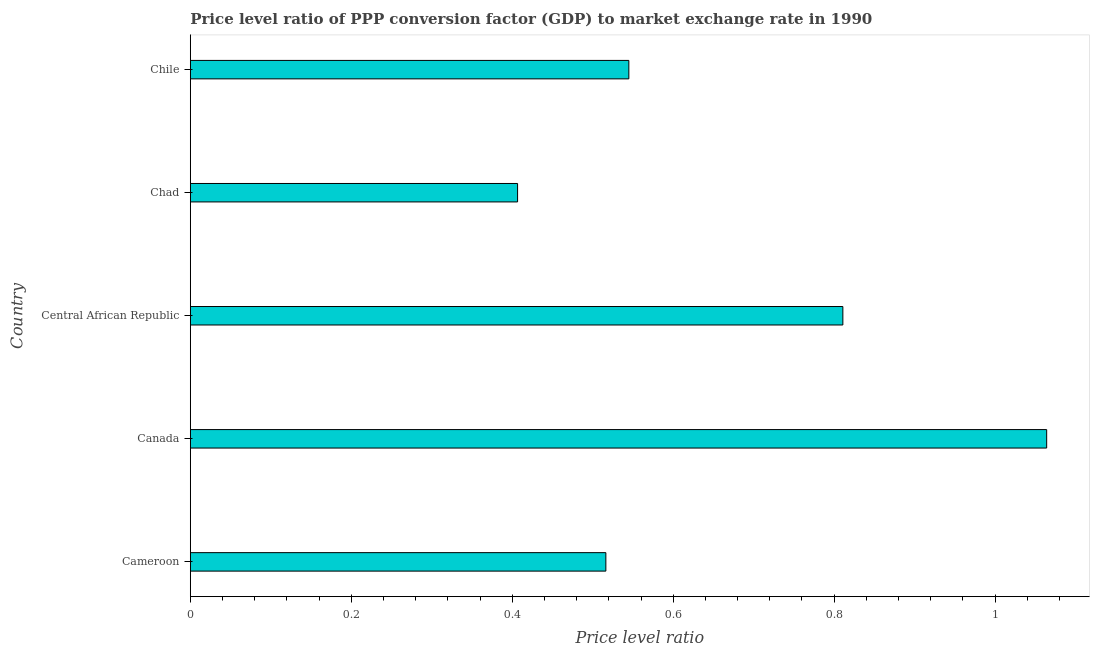Does the graph contain grids?
Offer a terse response. No. What is the title of the graph?
Give a very brief answer. Price level ratio of PPP conversion factor (GDP) to market exchange rate in 1990. What is the label or title of the X-axis?
Your answer should be compact. Price level ratio. What is the label or title of the Y-axis?
Ensure brevity in your answer.  Country. What is the price level ratio in Cameroon?
Give a very brief answer. 0.52. Across all countries, what is the maximum price level ratio?
Provide a short and direct response. 1.06. Across all countries, what is the minimum price level ratio?
Ensure brevity in your answer.  0.41. In which country was the price level ratio minimum?
Ensure brevity in your answer.  Chad. What is the sum of the price level ratio?
Provide a short and direct response. 3.34. What is the difference between the price level ratio in Central African Republic and Chile?
Your answer should be very brief. 0.27. What is the average price level ratio per country?
Keep it short and to the point. 0.67. What is the median price level ratio?
Your answer should be compact. 0.54. What is the ratio of the price level ratio in Central African Republic to that in Chad?
Give a very brief answer. 1.99. Is the difference between the price level ratio in Cameroon and Chad greater than the difference between any two countries?
Your response must be concise. No. What is the difference between the highest and the second highest price level ratio?
Your answer should be compact. 0.25. Is the sum of the price level ratio in Cameroon and Chile greater than the maximum price level ratio across all countries?
Keep it short and to the point. No. What is the difference between the highest and the lowest price level ratio?
Offer a terse response. 0.66. In how many countries, is the price level ratio greater than the average price level ratio taken over all countries?
Offer a very short reply. 2. Are all the bars in the graph horizontal?
Give a very brief answer. Yes. How many countries are there in the graph?
Your answer should be very brief. 5. What is the Price level ratio of Cameroon?
Offer a very short reply. 0.52. What is the Price level ratio of Canada?
Give a very brief answer. 1.06. What is the Price level ratio of Central African Republic?
Your response must be concise. 0.81. What is the Price level ratio in Chad?
Make the answer very short. 0.41. What is the Price level ratio of Chile?
Keep it short and to the point. 0.54. What is the difference between the Price level ratio in Cameroon and Canada?
Offer a terse response. -0.55. What is the difference between the Price level ratio in Cameroon and Central African Republic?
Make the answer very short. -0.29. What is the difference between the Price level ratio in Cameroon and Chad?
Provide a short and direct response. 0.11. What is the difference between the Price level ratio in Cameroon and Chile?
Provide a succinct answer. -0.03. What is the difference between the Price level ratio in Canada and Central African Republic?
Your response must be concise. 0.25. What is the difference between the Price level ratio in Canada and Chad?
Your answer should be compact. 0.66. What is the difference between the Price level ratio in Canada and Chile?
Ensure brevity in your answer.  0.52. What is the difference between the Price level ratio in Central African Republic and Chad?
Provide a short and direct response. 0.4. What is the difference between the Price level ratio in Central African Republic and Chile?
Give a very brief answer. 0.27. What is the difference between the Price level ratio in Chad and Chile?
Your answer should be compact. -0.14. What is the ratio of the Price level ratio in Cameroon to that in Canada?
Offer a terse response. 0.48. What is the ratio of the Price level ratio in Cameroon to that in Central African Republic?
Provide a succinct answer. 0.64. What is the ratio of the Price level ratio in Cameroon to that in Chad?
Your answer should be compact. 1.27. What is the ratio of the Price level ratio in Cameroon to that in Chile?
Your response must be concise. 0.95. What is the ratio of the Price level ratio in Canada to that in Central African Republic?
Offer a terse response. 1.31. What is the ratio of the Price level ratio in Canada to that in Chad?
Provide a succinct answer. 2.62. What is the ratio of the Price level ratio in Canada to that in Chile?
Your answer should be very brief. 1.95. What is the ratio of the Price level ratio in Central African Republic to that in Chad?
Ensure brevity in your answer.  1.99. What is the ratio of the Price level ratio in Central African Republic to that in Chile?
Make the answer very short. 1.49. What is the ratio of the Price level ratio in Chad to that in Chile?
Ensure brevity in your answer.  0.75. 